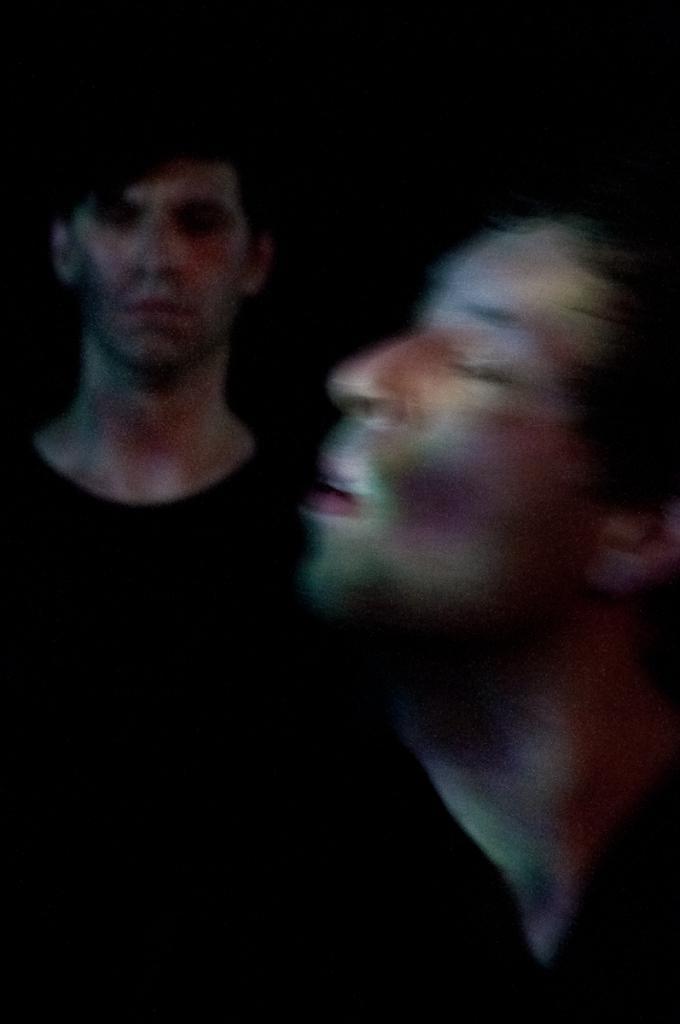In one or two sentences, can you explain what this image depicts? In this picture I can observe two members. The background is completely dark. 